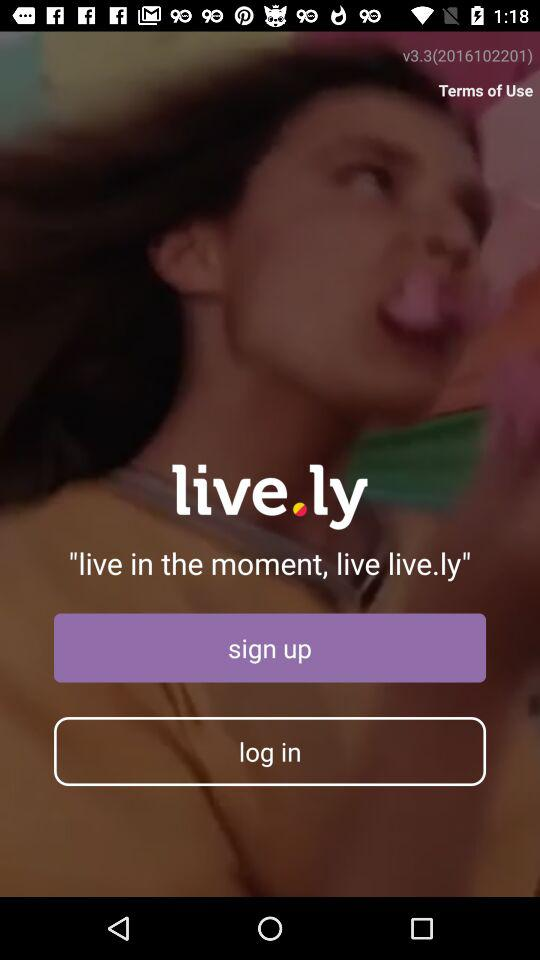Has the user agreed to the terms of use?
When the provided information is insufficient, respond with <no answer>. <no answer> 